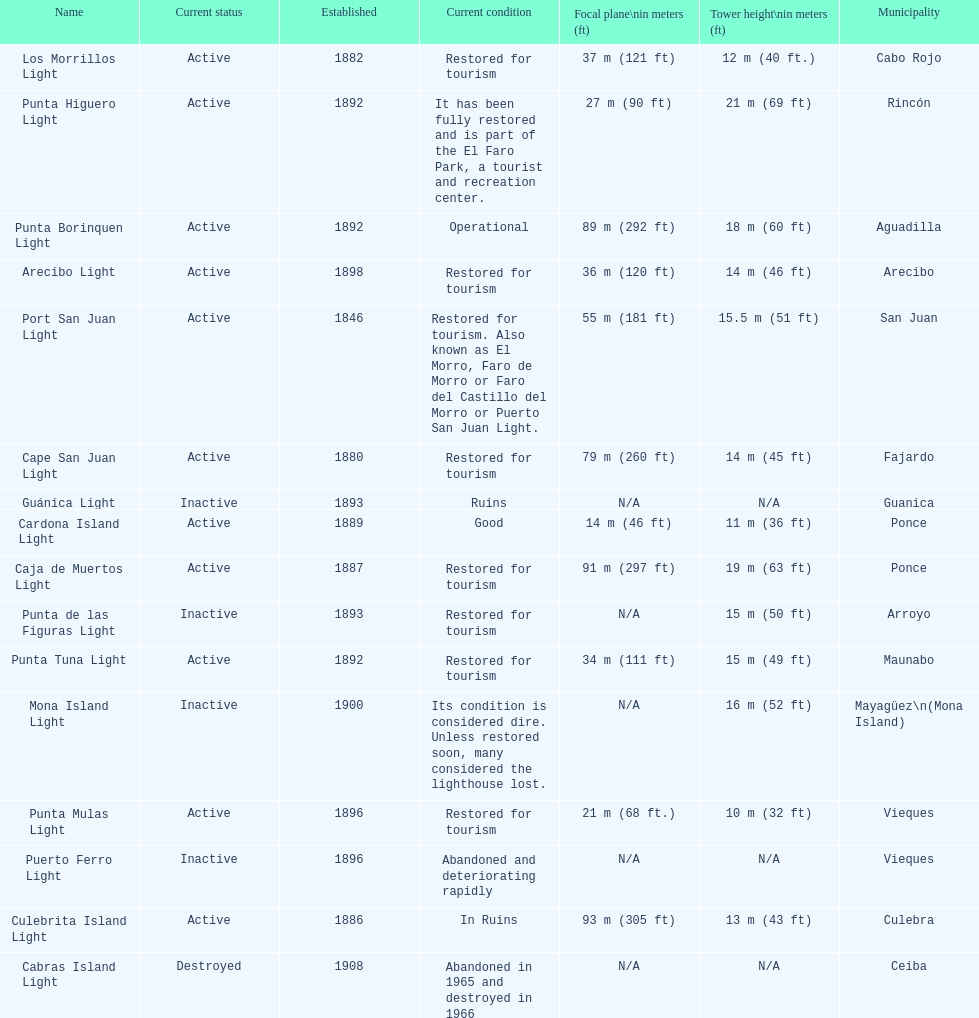Were any towers established before the year 1800? No. 